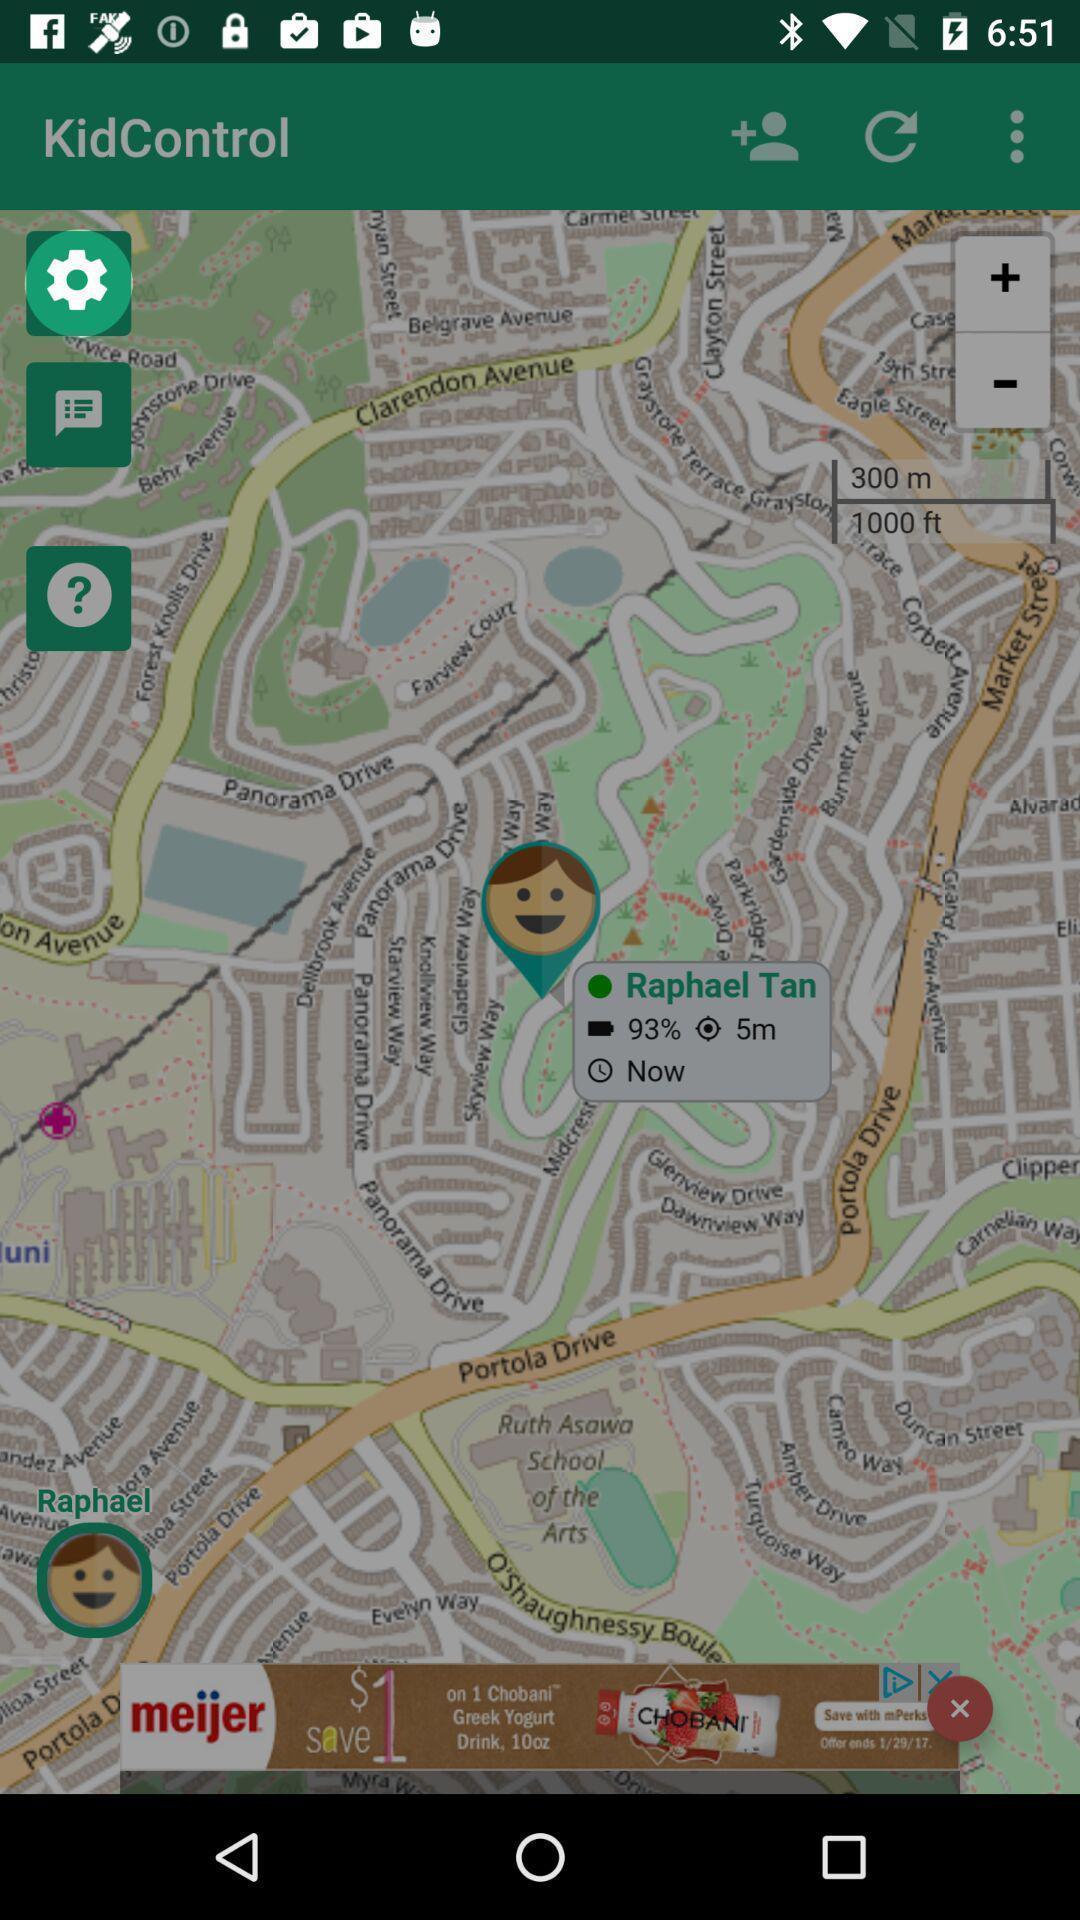Describe the key features of this screenshot. Settings button is highlighting in the page. 